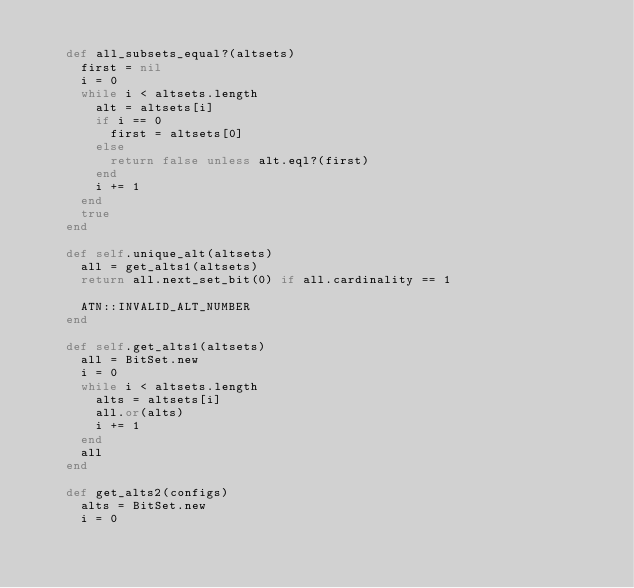Convert code to text. <code><loc_0><loc_0><loc_500><loc_500><_Ruby_>
    def all_subsets_equal?(altsets)
      first = nil
      i = 0
      while i < altsets.length
        alt = altsets[i]
        if i == 0
          first = altsets[0]
        else
          return false unless alt.eql?(first)
        end
        i += 1
      end
      true
    end

    def self.unique_alt(altsets)
      all = get_alts1(altsets)
      return all.next_set_bit(0) if all.cardinality == 1

      ATN::INVALID_ALT_NUMBER
    end

    def self.get_alts1(altsets)
      all = BitSet.new
      i = 0
      while i < altsets.length
        alts = altsets[i]
        all.or(alts)
        i += 1
      end
      all
    end

    def get_alts2(configs)
      alts = BitSet.new
      i = 0</code> 